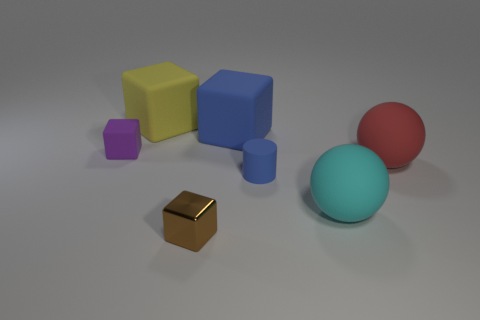Add 3 big yellow metallic cylinders. How many objects exist? 10 Subtract all blocks. How many objects are left? 3 Subtract all large blue rubber balls. Subtract all small purple objects. How many objects are left? 6 Add 3 large rubber spheres. How many large rubber spheres are left? 5 Add 5 small purple matte cylinders. How many small purple matte cylinders exist? 5 Subtract 1 blue blocks. How many objects are left? 6 